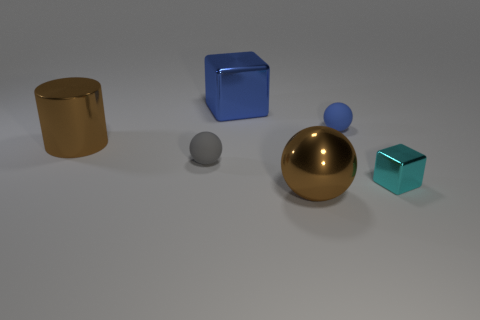Subtract all brown shiny spheres. How many spheres are left? 2 Add 1 blue metal spheres. How many objects exist? 7 Subtract all cylinders. How many objects are left? 5 Add 5 big blue things. How many big blue things are left? 6 Add 3 blue blocks. How many blue blocks exist? 4 Subtract 0 red spheres. How many objects are left? 6 Subtract all cyan balls. Subtract all cyan cylinders. How many balls are left? 3 Subtract all large metal cylinders. Subtract all cylinders. How many objects are left? 4 